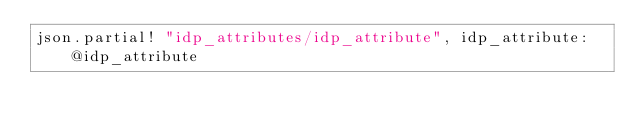<code> <loc_0><loc_0><loc_500><loc_500><_Ruby_>json.partial! "idp_attributes/idp_attribute", idp_attribute: @idp_attribute
</code> 